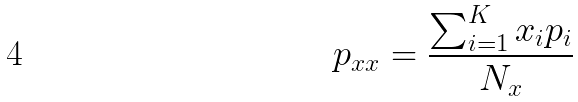Convert formula to latex. <formula><loc_0><loc_0><loc_500><loc_500>p _ { x x } = \frac { \sum _ { i = 1 } ^ { K } x _ { i } p _ { i } } { N _ { x } }</formula> 